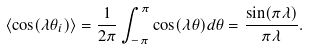<formula> <loc_0><loc_0><loc_500><loc_500>\langle \cos ( \lambda \theta _ { i } ) \rangle = \frac { 1 } { 2 \pi } \int _ { - \pi } ^ { \pi } \cos ( \lambda \theta ) d \theta = \frac { \sin ( \pi \lambda ) } { \pi \lambda } .</formula> 